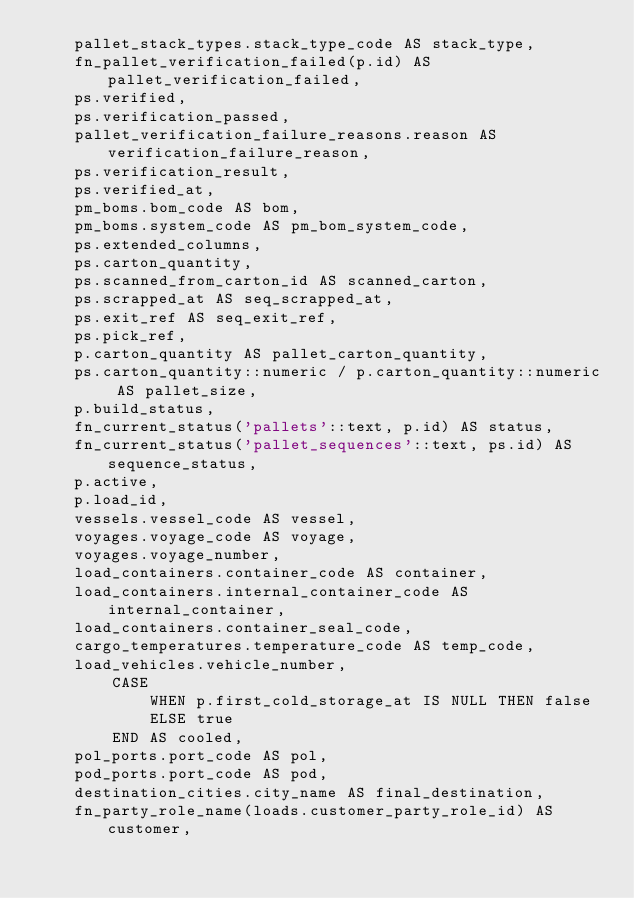<code> <loc_0><loc_0><loc_500><loc_500><_SQL_>    pallet_stack_types.stack_type_code AS stack_type,
    fn_pallet_verification_failed(p.id) AS pallet_verification_failed,
    ps.verified,
    ps.verification_passed,
    pallet_verification_failure_reasons.reason AS verification_failure_reason,
    ps.verification_result,
    ps.verified_at,
    pm_boms.bom_code AS bom,
    pm_boms.system_code AS pm_bom_system_code,
    ps.extended_columns,
    ps.carton_quantity,
    ps.scanned_from_carton_id AS scanned_carton,
    ps.scrapped_at AS seq_scrapped_at,
    ps.exit_ref AS seq_exit_ref,
    ps.pick_ref,
    p.carton_quantity AS pallet_carton_quantity,
    ps.carton_quantity::numeric / p.carton_quantity::numeric AS pallet_size,
    p.build_status,
    fn_current_status('pallets'::text, p.id) AS status,
    fn_current_status('pallet_sequences'::text, ps.id) AS sequence_status,
    p.active,
    p.load_id,
    vessels.vessel_code AS vessel,
    voyages.voyage_code AS voyage,
    voyages.voyage_number,
    load_containers.container_code AS container,
    load_containers.internal_container_code AS internal_container,
    load_containers.container_seal_code,
    cargo_temperatures.temperature_code AS temp_code,
    load_vehicles.vehicle_number,
        CASE
            WHEN p.first_cold_storage_at IS NULL THEN false
            ELSE true
        END AS cooled,
    pol_ports.port_code AS pol,
    pod_ports.port_code AS pod,
    destination_cities.city_name AS final_destination,
    fn_party_role_name(loads.customer_party_role_id) AS customer,</code> 